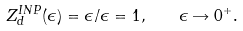Convert formula to latex. <formula><loc_0><loc_0><loc_500><loc_500>Z _ { d } ^ { I N P } ( \epsilon ) = \epsilon / \epsilon = 1 , \quad \epsilon \rightarrow 0 ^ { + } .</formula> 